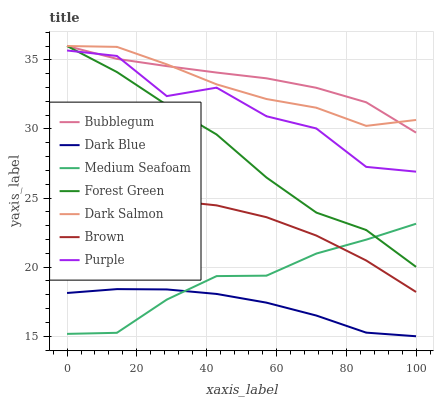Does Purple have the minimum area under the curve?
Answer yes or no. No. Does Purple have the maximum area under the curve?
Answer yes or no. No. Is Dark Salmon the smoothest?
Answer yes or no. No. Is Dark Salmon the roughest?
Answer yes or no. No. Does Purple have the lowest value?
Answer yes or no. No. Does Purple have the highest value?
Answer yes or no. No. Is Medium Seafoam less than Dark Salmon?
Answer yes or no. Yes. Is Purple greater than Medium Seafoam?
Answer yes or no. Yes. Does Medium Seafoam intersect Dark Salmon?
Answer yes or no. No. 